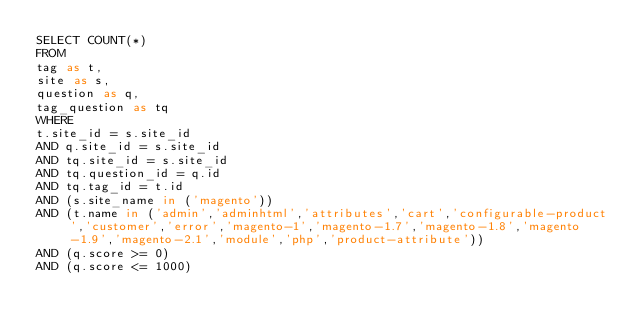<code> <loc_0><loc_0><loc_500><loc_500><_SQL_>SELECT COUNT(*)
FROM
tag as t,
site as s,
question as q,
tag_question as tq
WHERE
t.site_id = s.site_id
AND q.site_id = s.site_id
AND tq.site_id = s.site_id
AND tq.question_id = q.id
AND tq.tag_id = t.id
AND (s.site_name in ('magento'))
AND (t.name in ('admin','adminhtml','attributes','cart','configurable-product','customer','error','magento-1','magento-1.7','magento-1.8','magento-1.9','magento-2.1','module','php','product-attribute'))
AND (q.score >= 0)
AND (q.score <= 1000)
</code> 